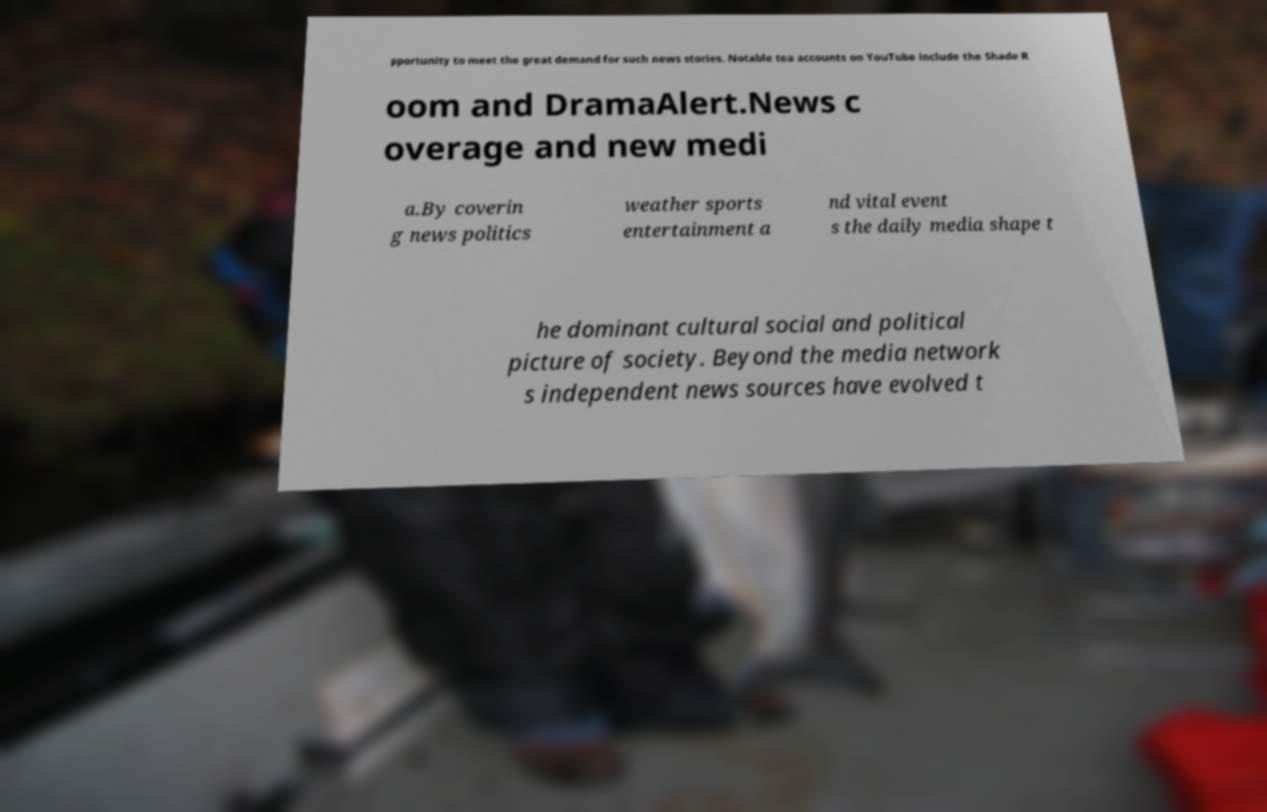For documentation purposes, I need the text within this image transcribed. Could you provide that? pportunity to meet the great demand for such news stories. Notable tea accounts on YouTube include the Shade R oom and DramaAlert.News c overage and new medi a.By coverin g news politics weather sports entertainment a nd vital event s the daily media shape t he dominant cultural social and political picture of society. Beyond the media network s independent news sources have evolved t 